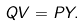<formula> <loc_0><loc_0><loc_500><loc_500>Q V = P Y .</formula> 